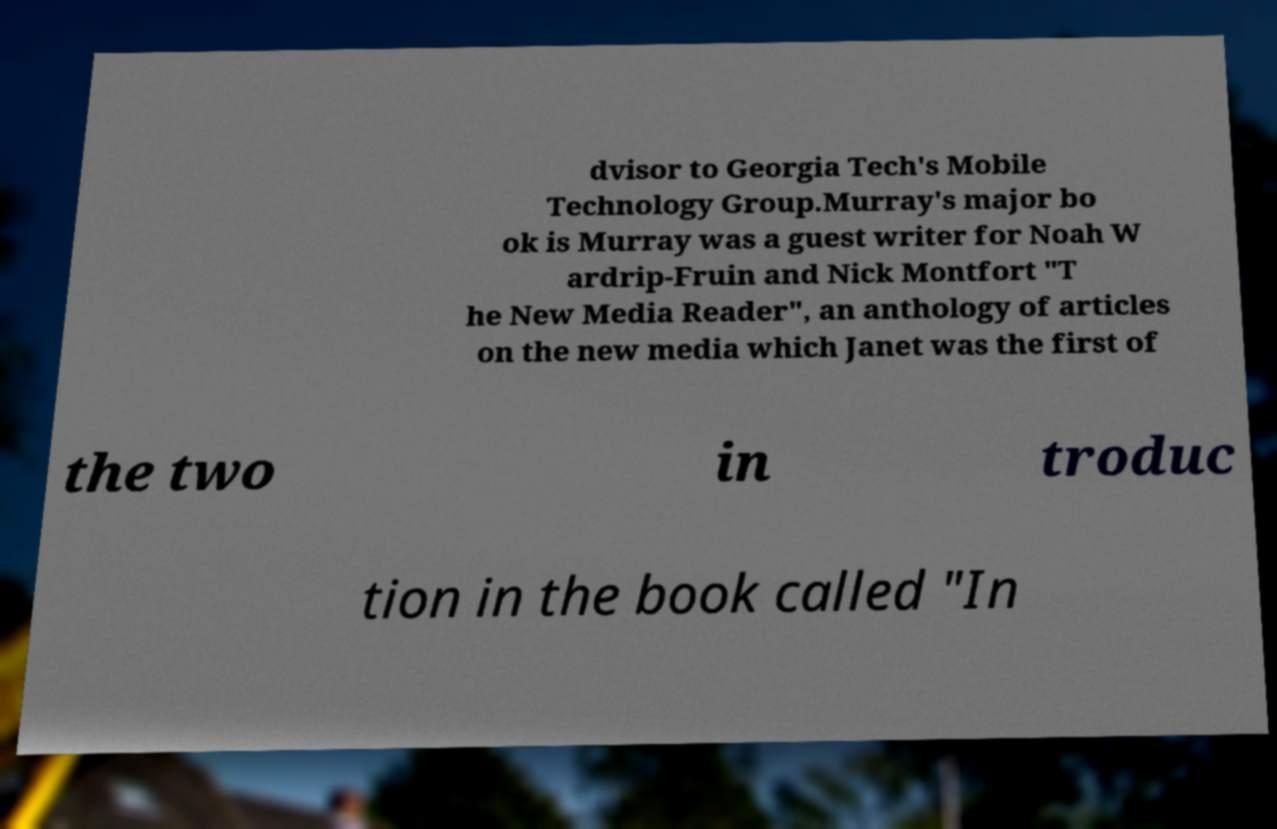Please identify and transcribe the text found in this image. dvisor to Georgia Tech's Mobile Technology Group.Murray's major bo ok is Murray was a guest writer for Noah W ardrip-Fruin and Nick Montfort "T he New Media Reader", an anthology of articles on the new media which Janet was the first of the two in troduc tion in the book called "In 